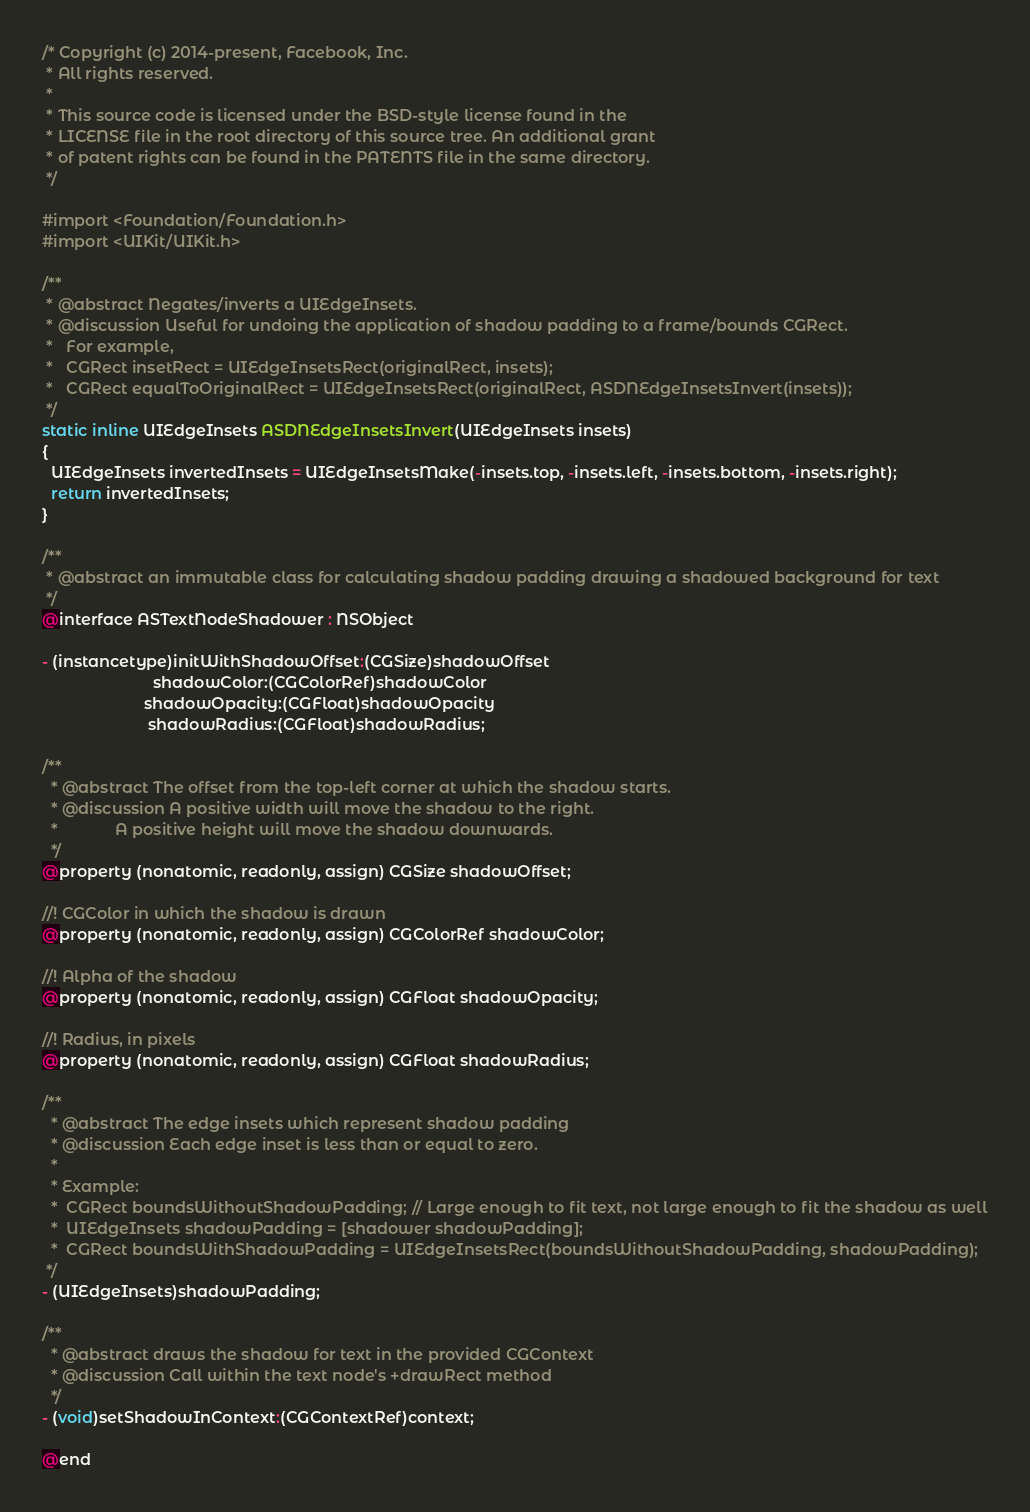<code> <loc_0><loc_0><loc_500><loc_500><_C_>/* Copyright (c) 2014-present, Facebook, Inc.
 * All rights reserved.
 *
 * This source code is licensed under the BSD-style license found in the
 * LICENSE file in the root directory of this source tree. An additional grant
 * of patent rights can be found in the PATENTS file in the same directory.
 */

#import <Foundation/Foundation.h>
#import <UIKit/UIKit.h>

/**
 * @abstract Negates/inverts a UIEdgeInsets.
 * @discussion Useful for undoing the application of shadow padding to a frame/bounds CGRect.
 *   For example,
 *   CGRect insetRect = UIEdgeInsetsRect(originalRect, insets);
 *   CGRect equalToOriginalRect = UIEdgeInsetsRect(originalRect, ASDNEdgeInsetsInvert(insets));
 */
static inline UIEdgeInsets ASDNEdgeInsetsInvert(UIEdgeInsets insets)
{
  UIEdgeInsets invertedInsets = UIEdgeInsetsMake(-insets.top, -insets.left, -insets.bottom, -insets.right);
  return invertedInsets;
}

/**
 * @abstract an immutable class for calculating shadow padding drawing a shadowed background for text
 */
@interface ASTextNodeShadower : NSObject

- (instancetype)initWithShadowOffset:(CGSize)shadowOffset
                         shadowColor:(CGColorRef)shadowColor
                       shadowOpacity:(CGFloat)shadowOpacity
                        shadowRadius:(CGFloat)shadowRadius;

/**
  * @abstract The offset from the top-left corner at which the shadow starts.
  * @discussion A positive width will move the shadow to the right.
  *             A positive height will move the shadow downwards.
  */
@property (nonatomic, readonly, assign) CGSize shadowOffset;

//! CGColor in which the shadow is drawn
@property (nonatomic, readonly, assign) CGColorRef shadowColor;

//! Alpha of the shadow
@property (nonatomic, readonly, assign) CGFloat shadowOpacity;

//! Radius, in pixels
@property (nonatomic, readonly, assign) CGFloat shadowRadius;

/**
  * @abstract The edge insets which represent shadow padding
  * @discussion Each edge inset is less than or equal to zero.
  *
  * Example:
  *  CGRect boundsWithoutShadowPadding; // Large enough to fit text, not large enough to fit the shadow as well
  *  UIEdgeInsets shadowPadding = [shadower shadowPadding];
  *  CGRect boundsWithShadowPadding = UIEdgeInsetsRect(boundsWithoutShadowPadding, shadowPadding);
 */
- (UIEdgeInsets)shadowPadding;

/**
  * @abstract draws the shadow for text in the provided CGContext
  * @discussion Call within the text node's +drawRect method
  */
- (void)setShadowInContext:(CGContextRef)context;

@end
</code> 